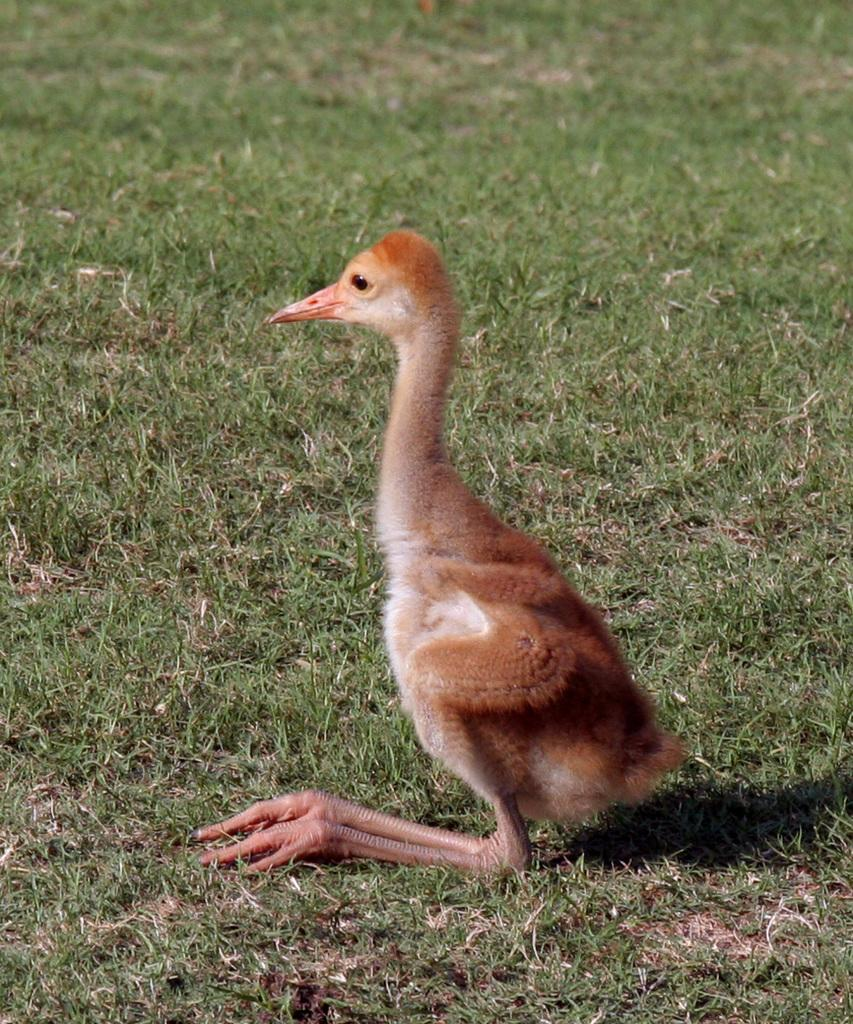What type of animal can be seen in the image? There is a brown-colored bird in the image. What is the background of the image? There is grass visible in the image. Can you describe any other element in the image? There is a shadow in the image. How many worms can be seen in the image? There are no worms present in the image. Is there a hen in the image? There is no hen present in the image. 